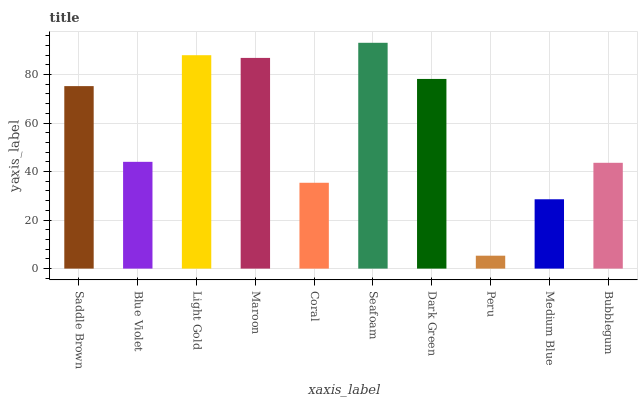Is Peru the minimum?
Answer yes or no. Yes. Is Seafoam the maximum?
Answer yes or no. Yes. Is Blue Violet the minimum?
Answer yes or no. No. Is Blue Violet the maximum?
Answer yes or no. No. Is Saddle Brown greater than Blue Violet?
Answer yes or no. Yes. Is Blue Violet less than Saddle Brown?
Answer yes or no. Yes. Is Blue Violet greater than Saddle Brown?
Answer yes or no. No. Is Saddle Brown less than Blue Violet?
Answer yes or no. No. Is Saddle Brown the high median?
Answer yes or no. Yes. Is Blue Violet the low median?
Answer yes or no. Yes. Is Medium Blue the high median?
Answer yes or no. No. Is Light Gold the low median?
Answer yes or no. No. 